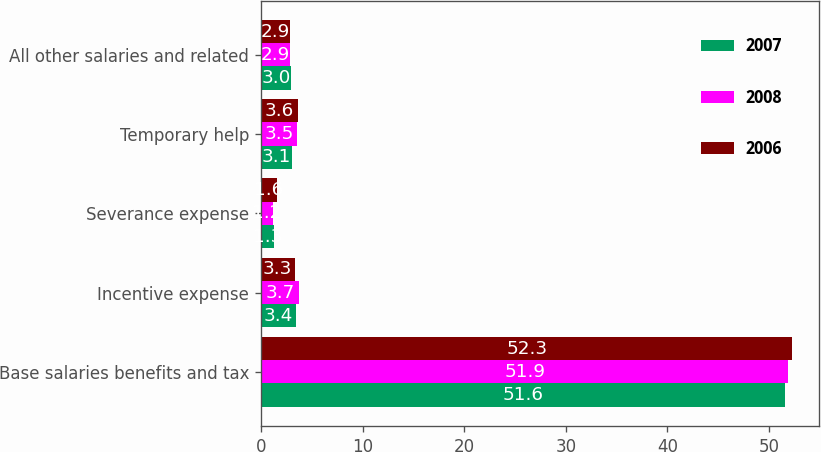Convert chart. <chart><loc_0><loc_0><loc_500><loc_500><stacked_bar_chart><ecel><fcel>Base salaries benefits and tax<fcel>Incentive expense<fcel>Severance expense<fcel>Temporary help<fcel>All other salaries and related<nl><fcel>2007<fcel>51.6<fcel>3.4<fcel>1.3<fcel>3.1<fcel>3<nl><fcel>2008<fcel>51.9<fcel>3.7<fcel>1.2<fcel>3.5<fcel>2.9<nl><fcel>2006<fcel>52.3<fcel>3.3<fcel>1.6<fcel>3.6<fcel>2.9<nl></chart> 